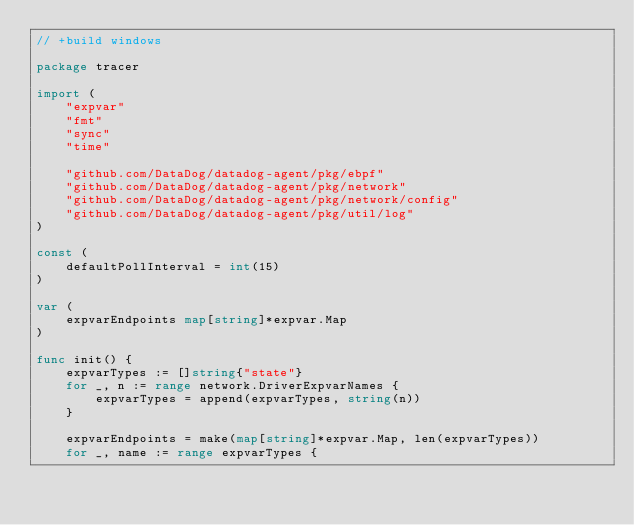<code> <loc_0><loc_0><loc_500><loc_500><_Go_>// +build windows

package tracer

import (
	"expvar"
	"fmt"
	"sync"
	"time"

	"github.com/DataDog/datadog-agent/pkg/ebpf"
	"github.com/DataDog/datadog-agent/pkg/network"
	"github.com/DataDog/datadog-agent/pkg/network/config"
	"github.com/DataDog/datadog-agent/pkg/util/log"
)

const (
	defaultPollInterval = int(15)
)

var (
	expvarEndpoints map[string]*expvar.Map
)

func init() {
	expvarTypes := []string{"state"}
	for _, n := range network.DriverExpvarNames {
		expvarTypes = append(expvarTypes, string(n))
	}

	expvarEndpoints = make(map[string]*expvar.Map, len(expvarTypes))
	for _, name := range expvarTypes {</code> 